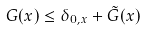<formula> <loc_0><loc_0><loc_500><loc_500>G ( x ) \leq \delta _ { 0 , x } + \tilde { G } ( x )</formula> 